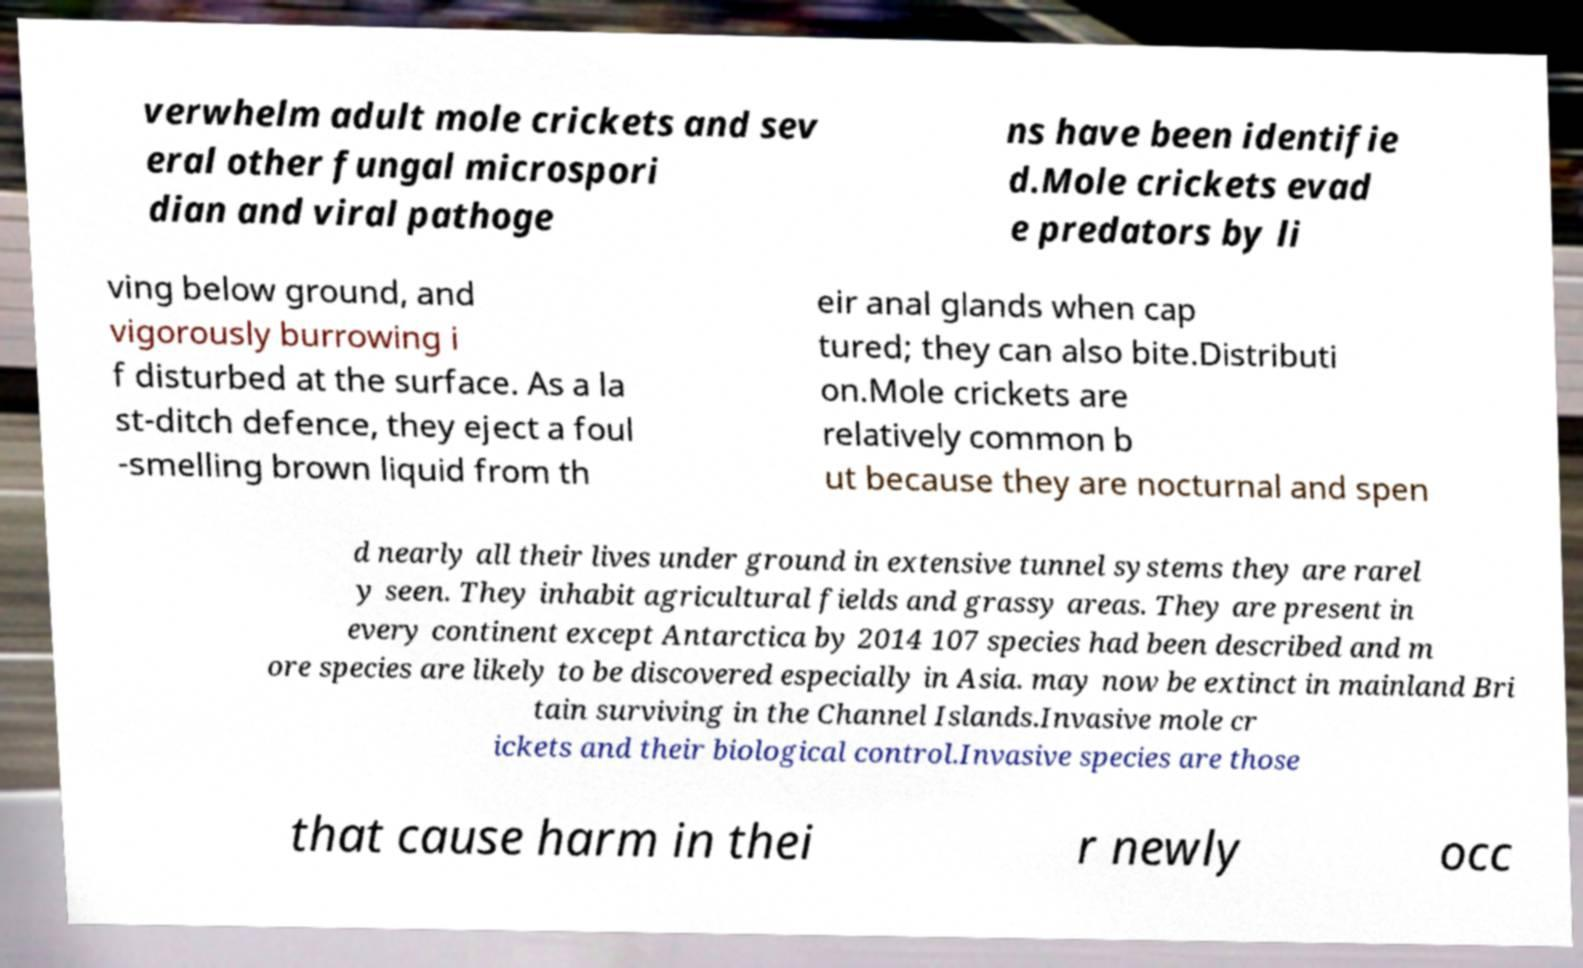What messages or text are displayed in this image? I need them in a readable, typed format. verwhelm adult mole crickets and sev eral other fungal microspori dian and viral pathoge ns have been identifie d.Mole crickets evad e predators by li ving below ground, and vigorously burrowing i f disturbed at the surface. As a la st-ditch defence, they eject a foul -smelling brown liquid from th eir anal glands when cap tured; they can also bite.Distributi on.Mole crickets are relatively common b ut because they are nocturnal and spen d nearly all their lives under ground in extensive tunnel systems they are rarel y seen. They inhabit agricultural fields and grassy areas. They are present in every continent except Antarctica by 2014 107 species had been described and m ore species are likely to be discovered especially in Asia. may now be extinct in mainland Bri tain surviving in the Channel Islands.Invasive mole cr ickets and their biological control.Invasive species are those that cause harm in thei r newly occ 